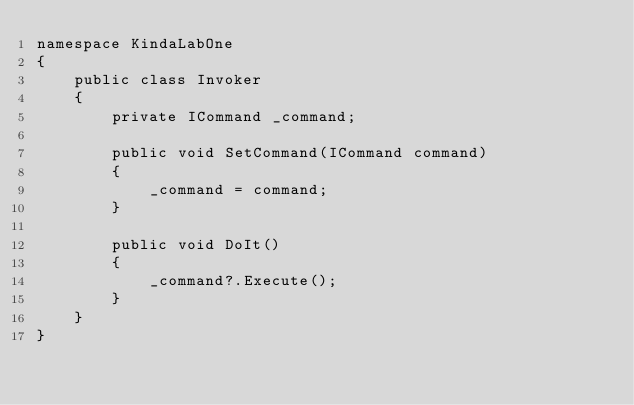<code> <loc_0><loc_0><loc_500><loc_500><_C#_>namespace KindaLabOne
{
    public class Invoker
    {
        private ICommand _command;
       
        public void SetCommand(ICommand command)
        {
            _command = command;
        }

        public void DoIt()
        {
            _command?.Execute();
        }
    }
}
</code> 